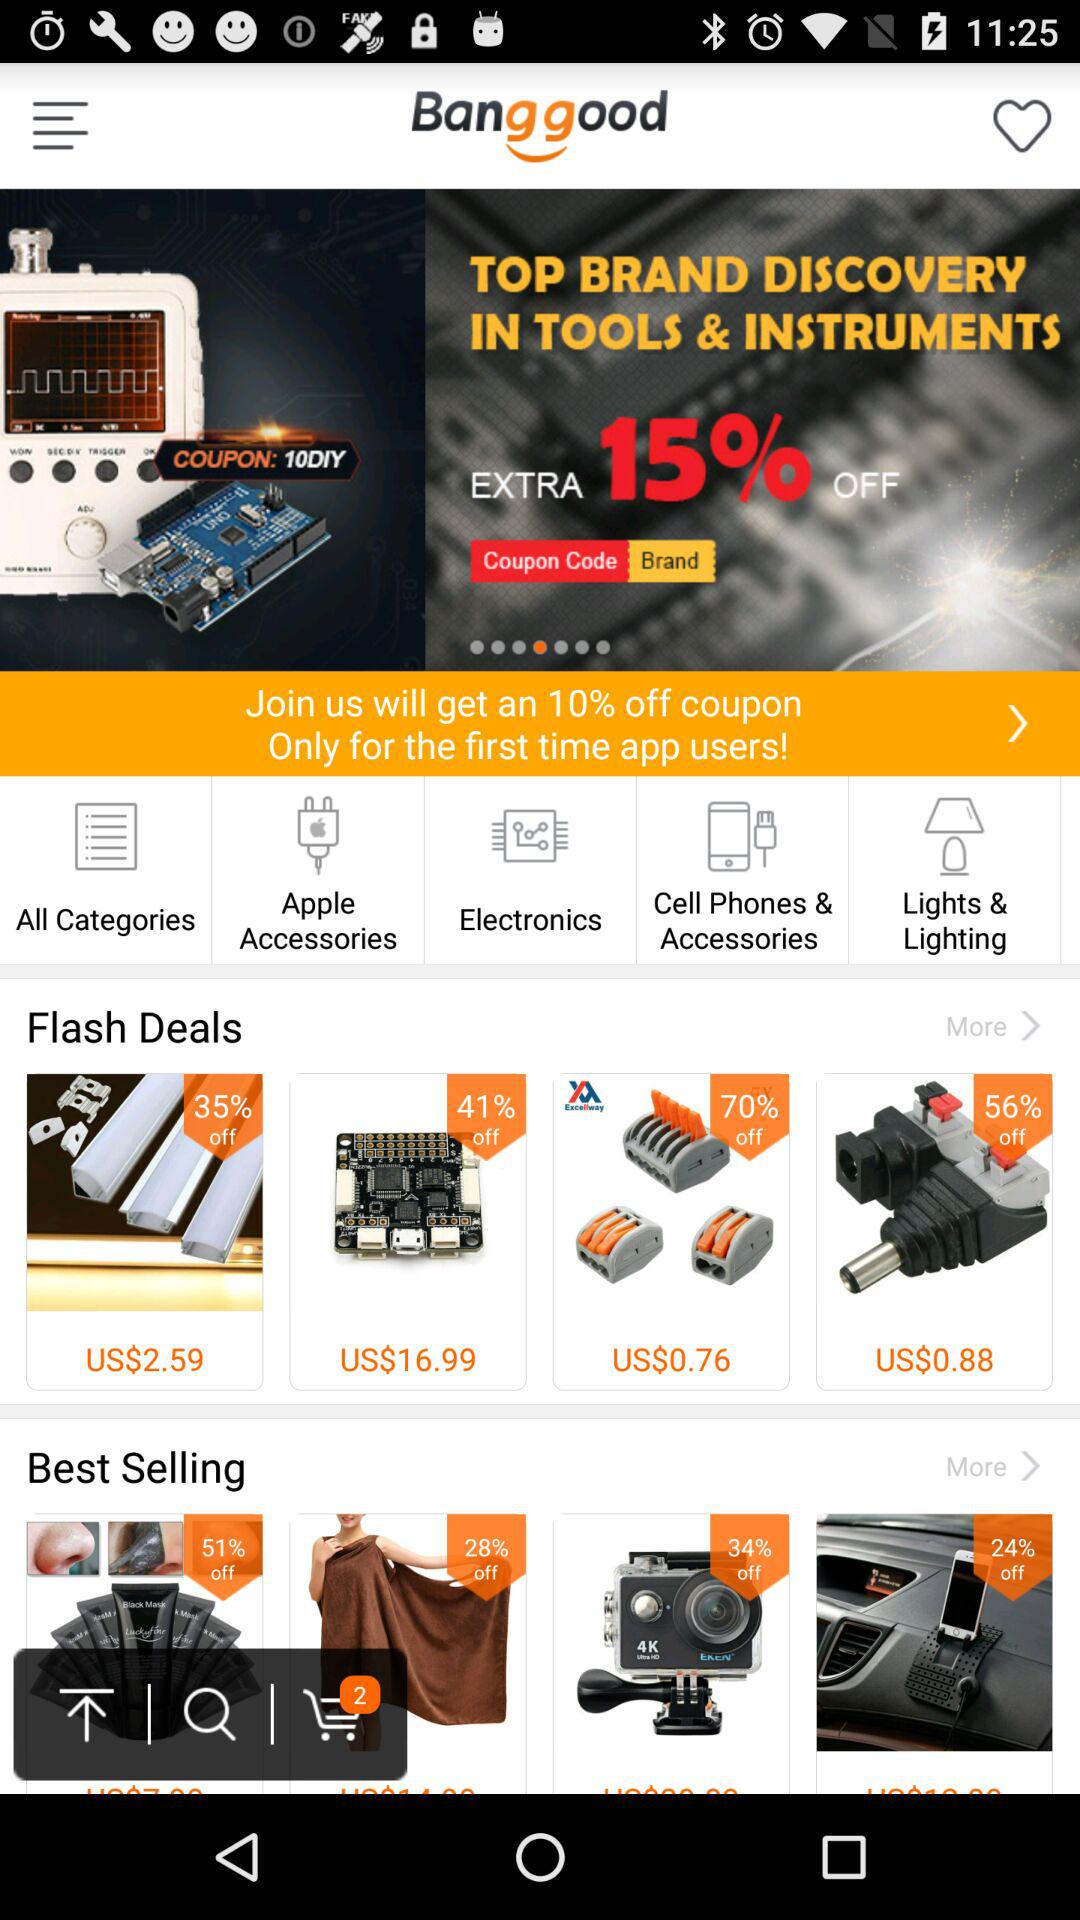What is the discount percentage on joining the "Banggood"? The discount is 10%. 